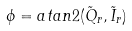<formula> <loc_0><loc_0><loc_500><loc_500>\phi = a t a n 2 ( \tilde { Q } _ { r } , \tilde { I } _ { r } )</formula> 